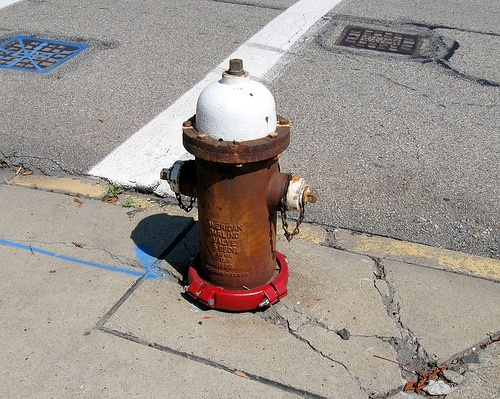Describe the objects in this image and their specific colors. I can see a fire hydrant in lightgray, black, maroon, white, and brown tones in this image. 